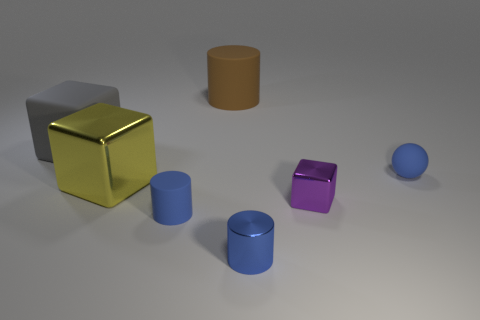Add 1 big yellow blocks. How many objects exist? 8 Subtract all spheres. How many objects are left? 6 Add 5 balls. How many balls are left? 6 Add 6 purple things. How many purple things exist? 7 Subtract 0 yellow balls. How many objects are left? 7 Subtract all blocks. Subtract all metal objects. How many objects are left? 1 